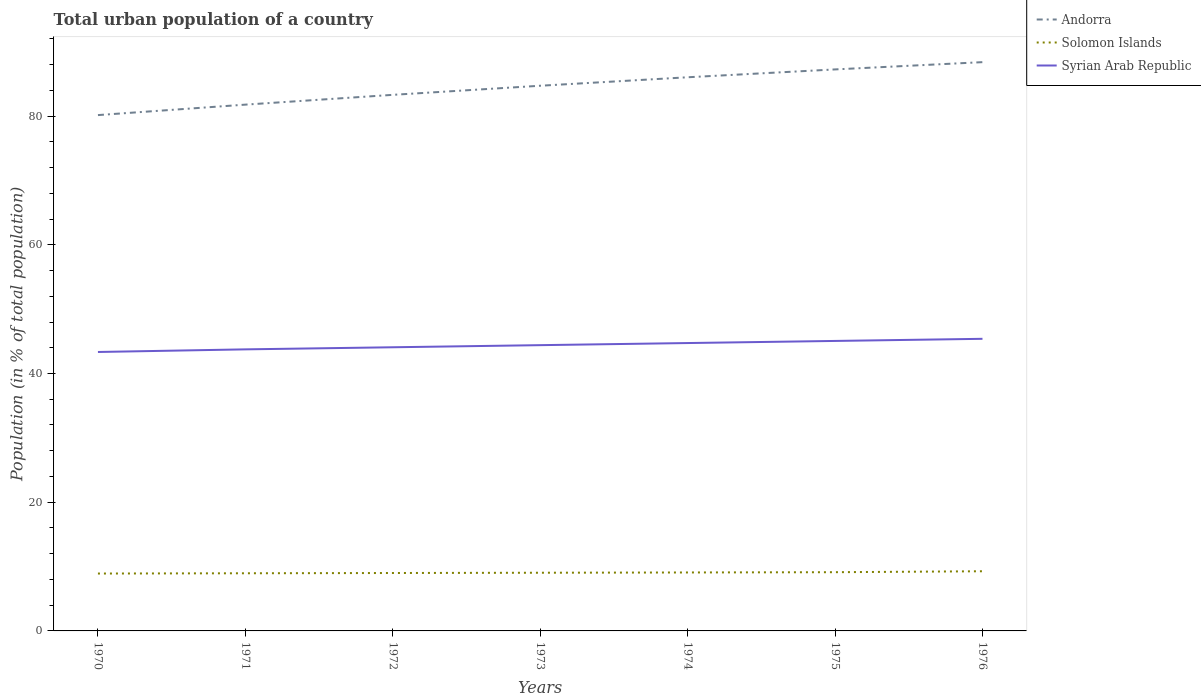How many different coloured lines are there?
Your answer should be compact. 3. Is the number of lines equal to the number of legend labels?
Your answer should be compact. Yes. Across all years, what is the maximum urban population in Solomon Islands?
Provide a succinct answer. 8.92. What is the total urban population in Andorra in the graph?
Give a very brief answer. -8.23. What is the difference between the highest and the second highest urban population in Solomon Islands?
Make the answer very short. 0.35. Is the urban population in Syrian Arab Republic strictly greater than the urban population in Solomon Islands over the years?
Offer a very short reply. No. How many lines are there?
Give a very brief answer. 3. Are the values on the major ticks of Y-axis written in scientific E-notation?
Ensure brevity in your answer.  No. How are the legend labels stacked?
Your response must be concise. Vertical. What is the title of the graph?
Make the answer very short. Total urban population of a country. What is the label or title of the Y-axis?
Keep it short and to the point. Population (in % of total population). What is the Population (in % of total population) in Andorra in 1970?
Offer a very short reply. 80.16. What is the Population (in % of total population) in Solomon Islands in 1970?
Provide a succinct answer. 8.92. What is the Population (in % of total population) in Syrian Arab Republic in 1970?
Give a very brief answer. 43.34. What is the Population (in % of total population) in Andorra in 1971?
Your answer should be very brief. 81.78. What is the Population (in % of total population) in Solomon Islands in 1971?
Your answer should be very brief. 8.96. What is the Population (in % of total population) in Syrian Arab Republic in 1971?
Offer a terse response. 43.75. What is the Population (in % of total population) of Andorra in 1972?
Give a very brief answer. 83.3. What is the Population (in % of total population) of Solomon Islands in 1972?
Provide a succinct answer. 9. What is the Population (in % of total population) of Syrian Arab Republic in 1972?
Provide a short and direct response. 44.08. What is the Population (in % of total population) of Andorra in 1973?
Offer a very short reply. 84.72. What is the Population (in % of total population) of Solomon Islands in 1973?
Your answer should be compact. 9.04. What is the Population (in % of total population) in Syrian Arab Republic in 1973?
Give a very brief answer. 44.41. What is the Population (in % of total population) of Andorra in 1974?
Offer a terse response. 86.03. What is the Population (in % of total population) in Solomon Islands in 1974?
Make the answer very short. 9.08. What is the Population (in % of total population) of Syrian Arab Republic in 1974?
Keep it short and to the point. 44.73. What is the Population (in % of total population) of Andorra in 1975?
Make the answer very short. 87.25. What is the Population (in % of total population) in Solomon Islands in 1975?
Your answer should be very brief. 9.12. What is the Population (in % of total population) of Syrian Arab Republic in 1975?
Your answer should be very brief. 45.06. What is the Population (in % of total population) in Andorra in 1976?
Keep it short and to the point. 88.38. What is the Population (in % of total population) in Solomon Islands in 1976?
Your response must be concise. 9.27. What is the Population (in % of total population) in Syrian Arab Republic in 1976?
Provide a succinct answer. 45.39. Across all years, what is the maximum Population (in % of total population) of Andorra?
Your answer should be compact. 88.38. Across all years, what is the maximum Population (in % of total population) of Solomon Islands?
Keep it short and to the point. 9.27. Across all years, what is the maximum Population (in % of total population) of Syrian Arab Republic?
Keep it short and to the point. 45.39. Across all years, what is the minimum Population (in % of total population) of Andorra?
Keep it short and to the point. 80.16. Across all years, what is the minimum Population (in % of total population) of Solomon Islands?
Make the answer very short. 8.92. Across all years, what is the minimum Population (in % of total population) in Syrian Arab Republic?
Your response must be concise. 43.34. What is the total Population (in % of total population) of Andorra in the graph?
Keep it short and to the point. 591.62. What is the total Population (in % of total population) in Solomon Islands in the graph?
Your response must be concise. 63.39. What is the total Population (in % of total population) in Syrian Arab Republic in the graph?
Your answer should be compact. 310.76. What is the difference between the Population (in % of total population) of Andorra in 1970 and that in 1971?
Provide a succinct answer. -1.62. What is the difference between the Population (in % of total population) in Solomon Islands in 1970 and that in 1971?
Ensure brevity in your answer.  -0.04. What is the difference between the Population (in % of total population) of Syrian Arab Republic in 1970 and that in 1971?
Provide a succinct answer. -0.41. What is the difference between the Population (in % of total population) in Andorra in 1970 and that in 1972?
Your answer should be compact. -3.15. What is the difference between the Population (in % of total population) of Solomon Islands in 1970 and that in 1972?
Your response must be concise. -0.08. What is the difference between the Population (in % of total population) of Syrian Arab Republic in 1970 and that in 1972?
Keep it short and to the point. -0.73. What is the difference between the Population (in % of total population) in Andorra in 1970 and that in 1973?
Offer a very short reply. -4.56. What is the difference between the Population (in % of total population) of Solomon Islands in 1970 and that in 1973?
Make the answer very short. -0.12. What is the difference between the Population (in % of total population) in Syrian Arab Republic in 1970 and that in 1973?
Ensure brevity in your answer.  -1.06. What is the difference between the Population (in % of total population) of Andorra in 1970 and that in 1974?
Ensure brevity in your answer.  -5.88. What is the difference between the Population (in % of total population) of Solomon Islands in 1970 and that in 1974?
Your answer should be very brief. -0.17. What is the difference between the Population (in % of total population) in Syrian Arab Republic in 1970 and that in 1974?
Your response must be concise. -1.39. What is the difference between the Population (in % of total population) of Andorra in 1970 and that in 1975?
Ensure brevity in your answer.  -7.1. What is the difference between the Population (in % of total population) of Solomon Islands in 1970 and that in 1975?
Offer a very short reply. -0.21. What is the difference between the Population (in % of total population) in Syrian Arab Republic in 1970 and that in 1975?
Offer a very short reply. -1.72. What is the difference between the Population (in % of total population) in Andorra in 1970 and that in 1976?
Make the answer very short. -8.23. What is the difference between the Population (in % of total population) in Solomon Islands in 1970 and that in 1976?
Offer a very short reply. -0.35. What is the difference between the Population (in % of total population) of Syrian Arab Republic in 1970 and that in 1976?
Your answer should be compact. -2.04. What is the difference between the Population (in % of total population) in Andorra in 1971 and that in 1972?
Your answer should be very brief. -1.52. What is the difference between the Population (in % of total population) in Solomon Islands in 1971 and that in 1972?
Offer a terse response. -0.04. What is the difference between the Population (in % of total population) in Syrian Arab Republic in 1971 and that in 1972?
Keep it short and to the point. -0.33. What is the difference between the Population (in % of total population) in Andorra in 1971 and that in 1973?
Provide a short and direct response. -2.94. What is the difference between the Population (in % of total population) in Solomon Islands in 1971 and that in 1973?
Your answer should be compact. -0.08. What is the difference between the Population (in % of total population) of Syrian Arab Republic in 1971 and that in 1973?
Keep it short and to the point. -0.65. What is the difference between the Population (in % of total population) in Andorra in 1971 and that in 1974?
Provide a short and direct response. -4.25. What is the difference between the Population (in % of total population) of Solomon Islands in 1971 and that in 1974?
Your answer should be compact. -0.12. What is the difference between the Population (in % of total population) of Syrian Arab Republic in 1971 and that in 1974?
Provide a short and direct response. -0.98. What is the difference between the Population (in % of total population) of Andorra in 1971 and that in 1975?
Give a very brief answer. -5.47. What is the difference between the Population (in % of total population) in Solomon Islands in 1971 and that in 1975?
Your answer should be very brief. -0.17. What is the difference between the Population (in % of total population) in Syrian Arab Republic in 1971 and that in 1975?
Give a very brief answer. -1.31. What is the difference between the Population (in % of total population) of Andorra in 1971 and that in 1976?
Your answer should be very brief. -6.6. What is the difference between the Population (in % of total population) in Solomon Islands in 1971 and that in 1976?
Your answer should be very brief. -0.31. What is the difference between the Population (in % of total population) in Syrian Arab Republic in 1971 and that in 1976?
Your response must be concise. -1.64. What is the difference between the Population (in % of total population) of Andorra in 1972 and that in 1973?
Your response must be concise. -1.42. What is the difference between the Population (in % of total population) in Solomon Islands in 1972 and that in 1973?
Your answer should be compact. -0.04. What is the difference between the Population (in % of total population) in Syrian Arab Republic in 1972 and that in 1973?
Your response must be concise. -0.33. What is the difference between the Population (in % of total population) in Andorra in 1972 and that in 1974?
Make the answer very short. -2.73. What is the difference between the Population (in % of total population) of Solomon Islands in 1972 and that in 1974?
Ensure brevity in your answer.  -0.08. What is the difference between the Population (in % of total population) in Syrian Arab Republic in 1972 and that in 1974?
Give a very brief answer. -0.66. What is the difference between the Population (in % of total population) in Andorra in 1972 and that in 1975?
Provide a succinct answer. -3.95. What is the difference between the Population (in % of total population) in Solomon Islands in 1972 and that in 1975?
Your answer should be compact. -0.13. What is the difference between the Population (in % of total population) of Syrian Arab Republic in 1972 and that in 1975?
Offer a very short reply. -0.98. What is the difference between the Population (in % of total population) in Andorra in 1972 and that in 1976?
Offer a very short reply. -5.08. What is the difference between the Population (in % of total population) of Solomon Islands in 1972 and that in 1976?
Your answer should be very brief. -0.27. What is the difference between the Population (in % of total population) of Syrian Arab Republic in 1972 and that in 1976?
Offer a terse response. -1.31. What is the difference between the Population (in % of total population) in Andorra in 1973 and that in 1974?
Ensure brevity in your answer.  -1.32. What is the difference between the Population (in % of total population) of Solomon Islands in 1973 and that in 1974?
Offer a terse response. -0.04. What is the difference between the Population (in % of total population) in Syrian Arab Republic in 1973 and that in 1974?
Your answer should be compact. -0.33. What is the difference between the Population (in % of total population) of Andorra in 1973 and that in 1975?
Offer a terse response. -2.54. What is the difference between the Population (in % of total population) in Solomon Islands in 1973 and that in 1975?
Your answer should be very brief. -0.08. What is the difference between the Population (in % of total population) of Syrian Arab Republic in 1973 and that in 1975?
Your response must be concise. -0.66. What is the difference between the Population (in % of total population) of Andorra in 1973 and that in 1976?
Ensure brevity in your answer.  -3.67. What is the difference between the Population (in % of total population) of Solomon Islands in 1973 and that in 1976?
Provide a succinct answer. -0.23. What is the difference between the Population (in % of total population) in Syrian Arab Republic in 1973 and that in 1976?
Keep it short and to the point. -0.98. What is the difference between the Population (in % of total population) of Andorra in 1974 and that in 1975?
Make the answer very short. -1.22. What is the difference between the Population (in % of total population) in Solomon Islands in 1974 and that in 1975?
Your response must be concise. -0.04. What is the difference between the Population (in % of total population) of Syrian Arab Republic in 1974 and that in 1975?
Your answer should be very brief. -0.33. What is the difference between the Population (in % of total population) of Andorra in 1974 and that in 1976?
Your answer should be compact. -2.35. What is the difference between the Population (in % of total population) in Solomon Islands in 1974 and that in 1976?
Ensure brevity in your answer.  -0.19. What is the difference between the Population (in % of total population) of Syrian Arab Republic in 1974 and that in 1976?
Offer a terse response. -0.66. What is the difference between the Population (in % of total population) in Andorra in 1975 and that in 1976?
Make the answer very short. -1.13. What is the difference between the Population (in % of total population) in Solomon Islands in 1975 and that in 1976?
Give a very brief answer. -0.15. What is the difference between the Population (in % of total population) in Syrian Arab Republic in 1975 and that in 1976?
Keep it short and to the point. -0.33. What is the difference between the Population (in % of total population) of Andorra in 1970 and the Population (in % of total population) of Solomon Islands in 1971?
Keep it short and to the point. 71.2. What is the difference between the Population (in % of total population) in Andorra in 1970 and the Population (in % of total population) in Syrian Arab Republic in 1971?
Your response must be concise. 36.4. What is the difference between the Population (in % of total population) of Solomon Islands in 1970 and the Population (in % of total population) of Syrian Arab Republic in 1971?
Provide a short and direct response. -34.83. What is the difference between the Population (in % of total population) of Andorra in 1970 and the Population (in % of total population) of Solomon Islands in 1972?
Ensure brevity in your answer.  71.16. What is the difference between the Population (in % of total population) in Andorra in 1970 and the Population (in % of total population) in Syrian Arab Republic in 1972?
Your response must be concise. 36.08. What is the difference between the Population (in % of total population) in Solomon Islands in 1970 and the Population (in % of total population) in Syrian Arab Republic in 1972?
Provide a succinct answer. -35.16. What is the difference between the Population (in % of total population) in Andorra in 1970 and the Population (in % of total population) in Solomon Islands in 1973?
Ensure brevity in your answer.  71.11. What is the difference between the Population (in % of total population) of Andorra in 1970 and the Population (in % of total population) of Syrian Arab Republic in 1973?
Make the answer very short. 35.75. What is the difference between the Population (in % of total population) in Solomon Islands in 1970 and the Population (in % of total population) in Syrian Arab Republic in 1973?
Your answer should be compact. -35.49. What is the difference between the Population (in % of total population) in Andorra in 1970 and the Population (in % of total population) in Solomon Islands in 1974?
Your response must be concise. 71.07. What is the difference between the Population (in % of total population) in Andorra in 1970 and the Population (in % of total population) in Syrian Arab Republic in 1974?
Make the answer very short. 35.42. What is the difference between the Population (in % of total population) of Solomon Islands in 1970 and the Population (in % of total population) of Syrian Arab Republic in 1974?
Your answer should be compact. -35.82. What is the difference between the Population (in % of total population) of Andorra in 1970 and the Population (in % of total population) of Solomon Islands in 1975?
Provide a short and direct response. 71.03. What is the difference between the Population (in % of total population) of Andorra in 1970 and the Population (in % of total population) of Syrian Arab Republic in 1975?
Ensure brevity in your answer.  35.09. What is the difference between the Population (in % of total population) of Solomon Islands in 1970 and the Population (in % of total population) of Syrian Arab Republic in 1975?
Offer a very short reply. -36.14. What is the difference between the Population (in % of total population) of Andorra in 1970 and the Population (in % of total population) of Solomon Islands in 1976?
Offer a very short reply. 70.88. What is the difference between the Population (in % of total population) in Andorra in 1970 and the Population (in % of total population) in Syrian Arab Republic in 1976?
Your response must be concise. 34.77. What is the difference between the Population (in % of total population) of Solomon Islands in 1970 and the Population (in % of total population) of Syrian Arab Republic in 1976?
Give a very brief answer. -36.47. What is the difference between the Population (in % of total population) in Andorra in 1971 and the Population (in % of total population) in Solomon Islands in 1972?
Your response must be concise. 72.78. What is the difference between the Population (in % of total population) in Andorra in 1971 and the Population (in % of total population) in Syrian Arab Republic in 1972?
Give a very brief answer. 37.7. What is the difference between the Population (in % of total population) in Solomon Islands in 1971 and the Population (in % of total population) in Syrian Arab Republic in 1972?
Ensure brevity in your answer.  -35.12. What is the difference between the Population (in % of total population) of Andorra in 1971 and the Population (in % of total population) of Solomon Islands in 1973?
Provide a succinct answer. 72.74. What is the difference between the Population (in % of total population) of Andorra in 1971 and the Population (in % of total population) of Syrian Arab Republic in 1973?
Your response must be concise. 37.38. What is the difference between the Population (in % of total population) in Solomon Islands in 1971 and the Population (in % of total population) in Syrian Arab Republic in 1973?
Ensure brevity in your answer.  -35.45. What is the difference between the Population (in % of total population) of Andorra in 1971 and the Population (in % of total population) of Solomon Islands in 1974?
Ensure brevity in your answer.  72.7. What is the difference between the Population (in % of total population) in Andorra in 1971 and the Population (in % of total population) in Syrian Arab Republic in 1974?
Your answer should be compact. 37.05. What is the difference between the Population (in % of total population) of Solomon Islands in 1971 and the Population (in % of total population) of Syrian Arab Republic in 1974?
Keep it short and to the point. -35.77. What is the difference between the Population (in % of total population) in Andorra in 1971 and the Population (in % of total population) in Solomon Islands in 1975?
Offer a very short reply. 72.66. What is the difference between the Population (in % of total population) of Andorra in 1971 and the Population (in % of total population) of Syrian Arab Republic in 1975?
Give a very brief answer. 36.72. What is the difference between the Population (in % of total population) in Solomon Islands in 1971 and the Population (in % of total population) in Syrian Arab Republic in 1975?
Ensure brevity in your answer.  -36.1. What is the difference between the Population (in % of total population) of Andorra in 1971 and the Population (in % of total population) of Solomon Islands in 1976?
Offer a very short reply. 72.51. What is the difference between the Population (in % of total population) of Andorra in 1971 and the Population (in % of total population) of Syrian Arab Republic in 1976?
Give a very brief answer. 36.39. What is the difference between the Population (in % of total population) in Solomon Islands in 1971 and the Population (in % of total population) in Syrian Arab Republic in 1976?
Ensure brevity in your answer.  -36.43. What is the difference between the Population (in % of total population) in Andorra in 1972 and the Population (in % of total population) in Solomon Islands in 1973?
Provide a succinct answer. 74.26. What is the difference between the Population (in % of total population) of Andorra in 1972 and the Population (in % of total population) of Syrian Arab Republic in 1973?
Give a very brief answer. 38.9. What is the difference between the Population (in % of total population) in Solomon Islands in 1972 and the Population (in % of total population) in Syrian Arab Republic in 1973?
Ensure brevity in your answer.  -35.41. What is the difference between the Population (in % of total population) of Andorra in 1972 and the Population (in % of total population) of Solomon Islands in 1974?
Your answer should be compact. 74.22. What is the difference between the Population (in % of total population) of Andorra in 1972 and the Population (in % of total population) of Syrian Arab Republic in 1974?
Ensure brevity in your answer.  38.57. What is the difference between the Population (in % of total population) of Solomon Islands in 1972 and the Population (in % of total population) of Syrian Arab Republic in 1974?
Offer a terse response. -35.73. What is the difference between the Population (in % of total population) of Andorra in 1972 and the Population (in % of total population) of Solomon Islands in 1975?
Your response must be concise. 74.18. What is the difference between the Population (in % of total population) in Andorra in 1972 and the Population (in % of total population) in Syrian Arab Republic in 1975?
Offer a terse response. 38.24. What is the difference between the Population (in % of total population) in Solomon Islands in 1972 and the Population (in % of total population) in Syrian Arab Republic in 1975?
Ensure brevity in your answer.  -36.06. What is the difference between the Population (in % of total population) of Andorra in 1972 and the Population (in % of total population) of Solomon Islands in 1976?
Make the answer very short. 74.03. What is the difference between the Population (in % of total population) in Andorra in 1972 and the Population (in % of total population) in Syrian Arab Republic in 1976?
Offer a terse response. 37.91. What is the difference between the Population (in % of total population) in Solomon Islands in 1972 and the Population (in % of total population) in Syrian Arab Republic in 1976?
Provide a short and direct response. -36.39. What is the difference between the Population (in % of total population) in Andorra in 1973 and the Population (in % of total population) in Solomon Islands in 1974?
Make the answer very short. 75.63. What is the difference between the Population (in % of total population) in Andorra in 1973 and the Population (in % of total population) in Syrian Arab Republic in 1974?
Ensure brevity in your answer.  39.98. What is the difference between the Population (in % of total population) of Solomon Islands in 1973 and the Population (in % of total population) of Syrian Arab Republic in 1974?
Your response must be concise. -35.69. What is the difference between the Population (in % of total population) of Andorra in 1973 and the Population (in % of total population) of Solomon Islands in 1975?
Give a very brief answer. 75.59. What is the difference between the Population (in % of total population) in Andorra in 1973 and the Population (in % of total population) in Syrian Arab Republic in 1975?
Your response must be concise. 39.66. What is the difference between the Population (in % of total population) of Solomon Islands in 1973 and the Population (in % of total population) of Syrian Arab Republic in 1975?
Make the answer very short. -36.02. What is the difference between the Population (in % of total population) of Andorra in 1973 and the Population (in % of total population) of Solomon Islands in 1976?
Keep it short and to the point. 75.44. What is the difference between the Population (in % of total population) of Andorra in 1973 and the Population (in % of total population) of Syrian Arab Republic in 1976?
Your answer should be very brief. 39.33. What is the difference between the Population (in % of total population) in Solomon Islands in 1973 and the Population (in % of total population) in Syrian Arab Republic in 1976?
Provide a short and direct response. -36.35. What is the difference between the Population (in % of total population) of Andorra in 1974 and the Population (in % of total population) of Solomon Islands in 1975?
Provide a succinct answer. 76.91. What is the difference between the Population (in % of total population) of Andorra in 1974 and the Population (in % of total population) of Syrian Arab Republic in 1975?
Your answer should be very brief. 40.97. What is the difference between the Population (in % of total population) of Solomon Islands in 1974 and the Population (in % of total population) of Syrian Arab Republic in 1975?
Make the answer very short. -35.98. What is the difference between the Population (in % of total population) of Andorra in 1974 and the Population (in % of total population) of Solomon Islands in 1976?
Your answer should be very brief. 76.76. What is the difference between the Population (in % of total population) of Andorra in 1974 and the Population (in % of total population) of Syrian Arab Republic in 1976?
Provide a succinct answer. 40.64. What is the difference between the Population (in % of total population) of Solomon Islands in 1974 and the Population (in % of total population) of Syrian Arab Republic in 1976?
Provide a short and direct response. -36.31. What is the difference between the Population (in % of total population) of Andorra in 1975 and the Population (in % of total population) of Solomon Islands in 1976?
Keep it short and to the point. 77.98. What is the difference between the Population (in % of total population) in Andorra in 1975 and the Population (in % of total population) in Syrian Arab Republic in 1976?
Your answer should be compact. 41.86. What is the difference between the Population (in % of total population) in Solomon Islands in 1975 and the Population (in % of total population) in Syrian Arab Republic in 1976?
Provide a short and direct response. -36.27. What is the average Population (in % of total population) in Andorra per year?
Offer a very short reply. 84.52. What is the average Population (in % of total population) of Solomon Islands per year?
Keep it short and to the point. 9.06. What is the average Population (in % of total population) in Syrian Arab Republic per year?
Provide a succinct answer. 44.39. In the year 1970, what is the difference between the Population (in % of total population) in Andorra and Population (in % of total population) in Solomon Islands?
Offer a very short reply. 71.24. In the year 1970, what is the difference between the Population (in % of total population) in Andorra and Population (in % of total population) in Syrian Arab Republic?
Offer a terse response. 36.81. In the year 1970, what is the difference between the Population (in % of total population) of Solomon Islands and Population (in % of total population) of Syrian Arab Republic?
Your response must be concise. -34.43. In the year 1971, what is the difference between the Population (in % of total population) of Andorra and Population (in % of total population) of Solomon Islands?
Offer a terse response. 72.82. In the year 1971, what is the difference between the Population (in % of total population) in Andorra and Population (in % of total population) in Syrian Arab Republic?
Offer a terse response. 38.03. In the year 1971, what is the difference between the Population (in % of total population) of Solomon Islands and Population (in % of total population) of Syrian Arab Republic?
Ensure brevity in your answer.  -34.79. In the year 1972, what is the difference between the Population (in % of total population) in Andorra and Population (in % of total population) in Solomon Islands?
Your answer should be compact. 74.3. In the year 1972, what is the difference between the Population (in % of total population) of Andorra and Population (in % of total population) of Syrian Arab Republic?
Make the answer very short. 39.22. In the year 1972, what is the difference between the Population (in % of total population) of Solomon Islands and Population (in % of total population) of Syrian Arab Republic?
Offer a very short reply. -35.08. In the year 1973, what is the difference between the Population (in % of total population) of Andorra and Population (in % of total population) of Solomon Islands?
Offer a terse response. 75.67. In the year 1973, what is the difference between the Population (in % of total population) in Andorra and Population (in % of total population) in Syrian Arab Republic?
Offer a very short reply. 40.31. In the year 1973, what is the difference between the Population (in % of total population) in Solomon Islands and Population (in % of total population) in Syrian Arab Republic?
Give a very brief answer. -35.36. In the year 1974, what is the difference between the Population (in % of total population) in Andorra and Population (in % of total population) in Solomon Islands?
Provide a short and direct response. 76.95. In the year 1974, what is the difference between the Population (in % of total population) of Andorra and Population (in % of total population) of Syrian Arab Republic?
Offer a terse response. 41.3. In the year 1974, what is the difference between the Population (in % of total population) of Solomon Islands and Population (in % of total population) of Syrian Arab Republic?
Ensure brevity in your answer.  -35.65. In the year 1975, what is the difference between the Population (in % of total population) of Andorra and Population (in % of total population) of Solomon Islands?
Ensure brevity in your answer.  78.13. In the year 1975, what is the difference between the Population (in % of total population) of Andorra and Population (in % of total population) of Syrian Arab Republic?
Your answer should be very brief. 42.19. In the year 1975, what is the difference between the Population (in % of total population) in Solomon Islands and Population (in % of total population) in Syrian Arab Republic?
Provide a succinct answer. -35.94. In the year 1976, what is the difference between the Population (in % of total population) of Andorra and Population (in % of total population) of Solomon Islands?
Provide a short and direct response. 79.11. In the year 1976, what is the difference between the Population (in % of total population) in Andorra and Population (in % of total population) in Syrian Arab Republic?
Provide a short and direct response. 42.99. In the year 1976, what is the difference between the Population (in % of total population) in Solomon Islands and Population (in % of total population) in Syrian Arab Republic?
Provide a succinct answer. -36.12. What is the ratio of the Population (in % of total population) in Andorra in 1970 to that in 1971?
Give a very brief answer. 0.98. What is the ratio of the Population (in % of total population) of Andorra in 1970 to that in 1972?
Your answer should be compact. 0.96. What is the ratio of the Population (in % of total population) of Solomon Islands in 1970 to that in 1972?
Offer a terse response. 0.99. What is the ratio of the Population (in % of total population) of Syrian Arab Republic in 1970 to that in 1972?
Your answer should be compact. 0.98. What is the ratio of the Population (in % of total population) in Andorra in 1970 to that in 1973?
Make the answer very short. 0.95. What is the ratio of the Population (in % of total population) in Solomon Islands in 1970 to that in 1973?
Provide a succinct answer. 0.99. What is the ratio of the Population (in % of total population) of Syrian Arab Republic in 1970 to that in 1973?
Your answer should be very brief. 0.98. What is the ratio of the Population (in % of total population) of Andorra in 1970 to that in 1974?
Provide a short and direct response. 0.93. What is the ratio of the Population (in % of total population) in Solomon Islands in 1970 to that in 1974?
Provide a short and direct response. 0.98. What is the ratio of the Population (in % of total population) in Syrian Arab Republic in 1970 to that in 1974?
Make the answer very short. 0.97. What is the ratio of the Population (in % of total population) in Andorra in 1970 to that in 1975?
Ensure brevity in your answer.  0.92. What is the ratio of the Population (in % of total population) in Solomon Islands in 1970 to that in 1975?
Keep it short and to the point. 0.98. What is the ratio of the Population (in % of total population) in Syrian Arab Republic in 1970 to that in 1975?
Offer a very short reply. 0.96. What is the ratio of the Population (in % of total population) of Andorra in 1970 to that in 1976?
Give a very brief answer. 0.91. What is the ratio of the Population (in % of total population) of Solomon Islands in 1970 to that in 1976?
Give a very brief answer. 0.96. What is the ratio of the Population (in % of total population) of Syrian Arab Republic in 1970 to that in 1976?
Offer a very short reply. 0.95. What is the ratio of the Population (in % of total population) of Andorra in 1971 to that in 1972?
Keep it short and to the point. 0.98. What is the ratio of the Population (in % of total population) of Syrian Arab Republic in 1971 to that in 1972?
Ensure brevity in your answer.  0.99. What is the ratio of the Population (in % of total population) in Andorra in 1971 to that in 1973?
Ensure brevity in your answer.  0.97. What is the ratio of the Population (in % of total population) in Solomon Islands in 1971 to that in 1973?
Give a very brief answer. 0.99. What is the ratio of the Population (in % of total population) in Syrian Arab Republic in 1971 to that in 1973?
Ensure brevity in your answer.  0.99. What is the ratio of the Population (in % of total population) of Andorra in 1971 to that in 1974?
Ensure brevity in your answer.  0.95. What is the ratio of the Population (in % of total population) of Solomon Islands in 1971 to that in 1974?
Provide a short and direct response. 0.99. What is the ratio of the Population (in % of total population) in Syrian Arab Republic in 1971 to that in 1974?
Provide a short and direct response. 0.98. What is the ratio of the Population (in % of total population) in Andorra in 1971 to that in 1975?
Keep it short and to the point. 0.94. What is the ratio of the Population (in % of total population) in Solomon Islands in 1971 to that in 1975?
Keep it short and to the point. 0.98. What is the ratio of the Population (in % of total population) in Syrian Arab Republic in 1971 to that in 1975?
Keep it short and to the point. 0.97. What is the ratio of the Population (in % of total population) of Andorra in 1971 to that in 1976?
Your answer should be very brief. 0.93. What is the ratio of the Population (in % of total population) of Solomon Islands in 1971 to that in 1976?
Ensure brevity in your answer.  0.97. What is the ratio of the Population (in % of total population) in Syrian Arab Republic in 1971 to that in 1976?
Ensure brevity in your answer.  0.96. What is the ratio of the Population (in % of total population) of Andorra in 1972 to that in 1973?
Your answer should be very brief. 0.98. What is the ratio of the Population (in % of total population) of Solomon Islands in 1972 to that in 1973?
Your response must be concise. 1. What is the ratio of the Population (in % of total population) in Andorra in 1972 to that in 1974?
Provide a short and direct response. 0.97. What is the ratio of the Population (in % of total population) in Solomon Islands in 1972 to that in 1974?
Offer a very short reply. 0.99. What is the ratio of the Population (in % of total population) of Syrian Arab Republic in 1972 to that in 1974?
Offer a very short reply. 0.99. What is the ratio of the Population (in % of total population) of Andorra in 1972 to that in 1975?
Offer a very short reply. 0.95. What is the ratio of the Population (in % of total population) of Solomon Islands in 1972 to that in 1975?
Your answer should be very brief. 0.99. What is the ratio of the Population (in % of total population) in Syrian Arab Republic in 1972 to that in 1975?
Provide a succinct answer. 0.98. What is the ratio of the Population (in % of total population) of Andorra in 1972 to that in 1976?
Your answer should be very brief. 0.94. What is the ratio of the Population (in % of total population) in Solomon Islands in 1972 to that in 1976?
Provide a succinct answer. 0.97. What is the ratio of the Population (in % of total population) in Syrian Arab Republic in 1972 to that in 1976?
Provide a short and direct response. 0.97. What is the ratio of the Population (in % of total population) of Andorra in 1973 to that in 1974?
Make the answer very short. 0.98. What is the ratio of the Population (in % of total population) of Solomon Islands in 1973 to that in 1974?
Your answer should be very brief. 1. What is the ratio of the Population (in % of total population) of Syrian Arab Republic in 1973 to that in 1974?
Provide a short and direct response. 0.99. What is the ratio of the Population (in % of total population) in Andorra in 1973 to that in 1975?
Your answer should be compact. 0.97. What is the ratio of the Population (in % of total population) of Solomon Islands in 1973 to that in 1975?
Provide a short and direct response. 0.99. What is the ratio of the Population (in % of total population) of Syrian Arab Republic in 1973 to that in 1975?
Provide a succinct answer. 0.99. What is the ratio of the Population (in % of total population) of Andorra in 1973 to that in 1976?
Your answer should be very brief. 0.96. What is the ratio of the Population (in % of total population) in Solomon Islands in 1973 to that in 1976?
Make the answer very short. 0.98. What is the ratio of the Population (in % of total population) of Syrian Arab Republic in 1973 to that in 1976?
Your answer should be compact. 0.98. What is the ratio of the Population (in % of total population) of Andorra in 1974 to that in 1975?
Offer a terse response. 0.99. What is the ratio of the Population (in % of total population) of Solomon Islands in 1974 to that in 1975?
Make the answer very short. 1. What is the ratio of the Population (in % of total population) in Andorra in 1974 to that in 1976?
Your answer should be very brief. 0.97. What is the ratio of the Population (in % of total population) of Solomon Islands in 1974 to that in 1976?
Provide a succinct answer. 0.98. What is the ratio of the Population (in % of total population) in Syrian Arab Republic in 1974 to that in 1976?
Keep it short and to the point. 0.99. What is the ratio of the Population (in % of total population) of Andorra in 1975 to that in 1976?
Provide a succinct answer. 0.99. What is the ratio of the Population (in % of total population) in Solomon Islands in 1975 to that in 1976?
Make the answer very short. 0.98. What is the ratio of the Population (in % of total population) in Syrian Arab Republic in 1975 to that in 1976?
Your answer should be compact. 0.99. What is the difference between the highest and the second highest Population (in % of total population) of Andorra?
Keep it short and to the point. 1.13. What is the difference between the highest and the second highest Population (in % of total population) in Solomon Islands?
Your answer should be compact. 0.15. What is the difference between the highest and the second highest Population (in % of total population) of Syrian Arab Republic?
Your response must be concise. 0.33. What is the difference between the highest and the lowest Population (in % of total population) of Andorra?
Offer a very short reply. 8.23. What is the difference between the highest and the lowest Population (in % of total population) of Solomon Islands?
Provide a short and direct response. 0.35. What is the difference between the highest and the lowest Population (in % of total population) in Syrian Arab Republic?
Offer a terse response. 2.04. 